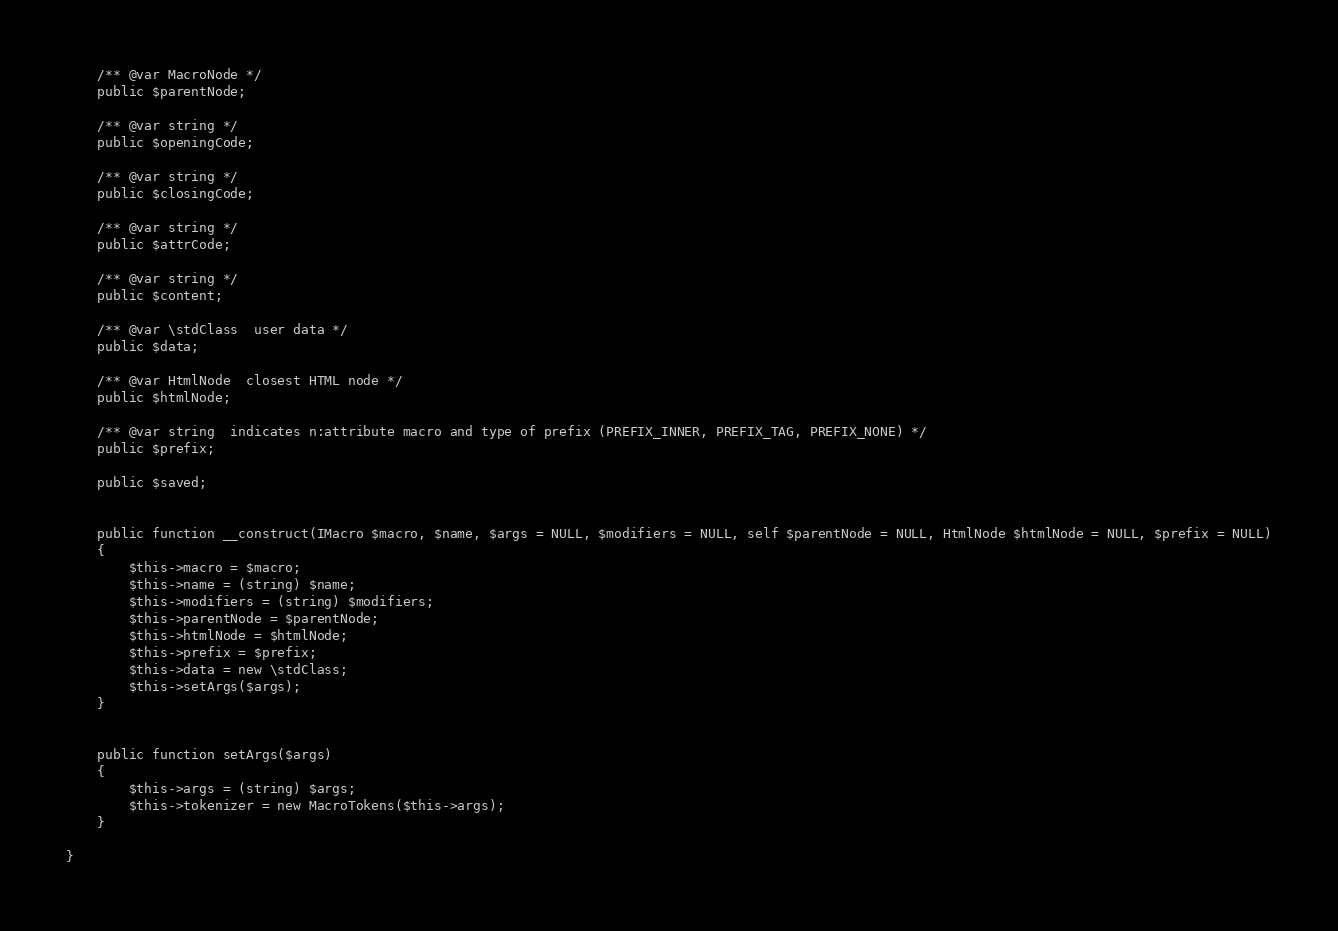<code> <loc_0><loc_0><loc_500><loc_500><_PHP_>	/** @var MacroNode */
	public $parentNode;

	/** @var string */
	public $openingCode;

	/** @var string */
	public $closingCode;

	/** @var string */
	public $attrCode;

	/** @var string */
	public $content;

	/** @var \stdClass  user data */
	public $data;

	/** @var HtmlNode  closest HTML node */
	public $htmlNode;

	/** @var string  indicates n:attribute macro and type of prefix (PREFIX_INNER, PREFIX_TAG, PREFIX_NONE) */
	public $prefix;

	public $saved;


	public function __construct(IMacro $macro, $name, $args = NULL, $modifiers = NULL, self $parentNode = NULL, HtmlNode $htmlNode = NULL, $prefix = NULL)
	{
		$this->macro = $macro;
		$this->name = (string) $name;
		$this->modifiers = (string) $modifiers;
		$this->parentNode = $parentNode;
		$this->htmlNode = $htmlNode;
		$this->prefix = $prefix;
		$this->data = new \stdClass;
		$this->setArgs($args);
	}


	public function setArgs($args)
	{
		$this->args = (string) $args;
		$this->tokenizer = new MacroTokens($this->args);
	}

}
</code> 